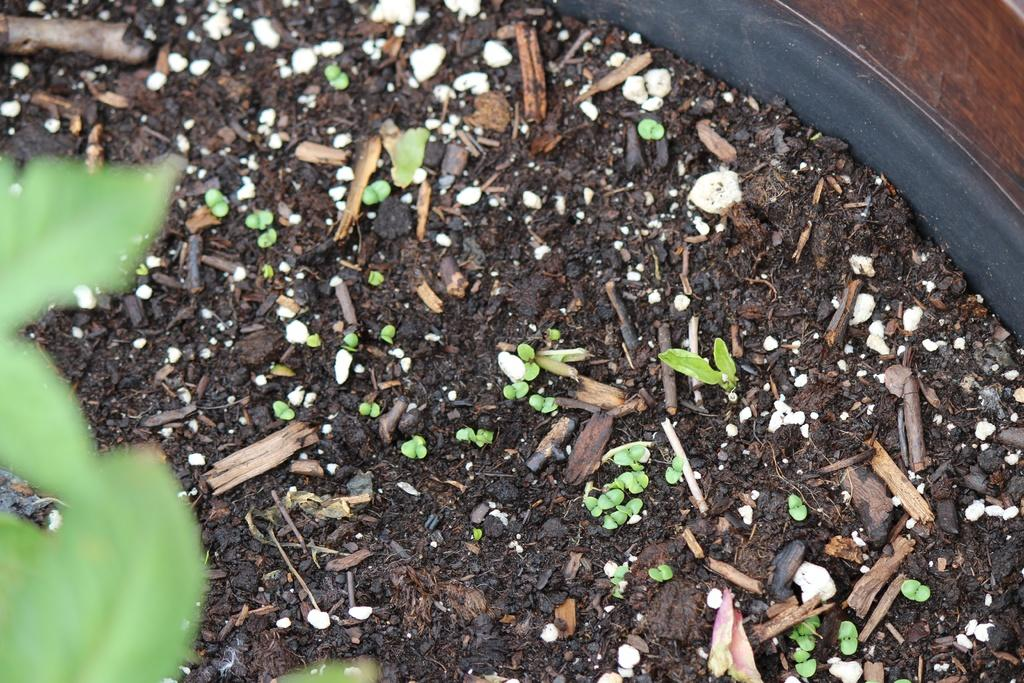What type of surface is visible in the image? The image contains soil with tiny particles. Where are the leaves located in the image? The leaves are in the bottom left corner of the image. What type of knife can be seen attacking the moon in the image? There is no knife or moon present in the image; it only contains soil and leaves. 